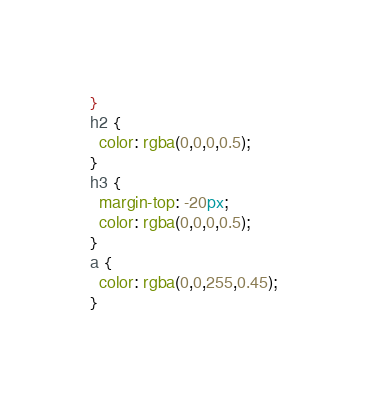<code> <loc_0><loc_0><loc_500><loc_500><_CSS_>}
h2 {
  color: rgba(0,0,0,0.5);
}
h3 {
  margin-top: -20px;
  color: rgba(0,0,0,0.5);
}
a {
  color: rgba(0,0,255,0.45);
}</code> 